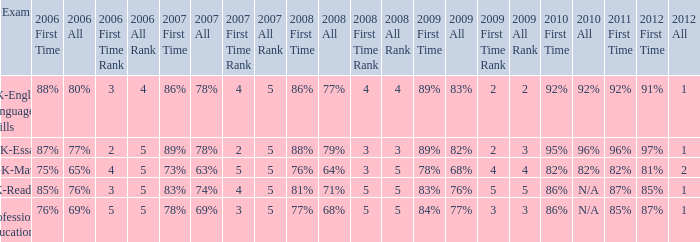What is the percentage for 2008 First time when in 2006 it was 85%? 81%. 